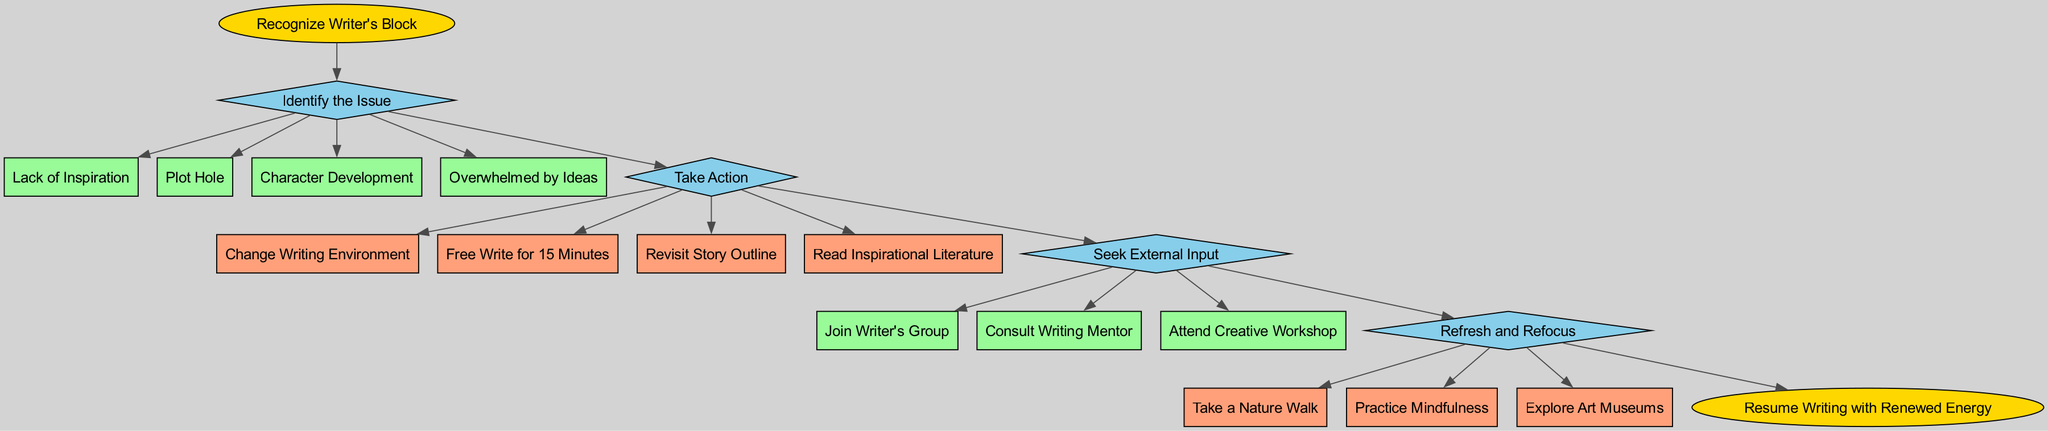What is the starting point of the flowchart? The starting point is represented by the first node labeled "Recognize Writer's Block." This node is connected to the "Identify the Issue" stage, indicating it is the initial action.
Answer: Recognize Writer's Block How many stages are present in the flowchart? The flowchart includes four distinct stages: "Identify the Issue," "Take Action," "Seek External Input," and "Refresh and Refocus." By counting these stages, we can determine the total.
Answer: 4 What is one option in the "Identify the Issue" stage? In the "Identify the Issue" stage, one of the listed options is "Lack of Inspiration." This represents a potential reason for experiencing writer's block.
Answer: Lack of Inspiration What action should be taken if the writer feels overwhelmed by ideas? When the feeling of being overwhelmed by ideas is identified, the writer should proceed to the "Take Action" stage. One action listed there is to "Free Write for 15 Minutes." This indicates a direct approach to cope with the issue.
Answer: Free Write for 15 Minutes What is the last action in the flowchart before resuming writing? The flowchart ends with the node "Resume Writing with Renewed Energy." This indicates that after taking previous steps, the final action is to return to writing with a fresh mindset.
Answer: Resume Writing with Renewed Energy If a writer wants external input, what is one of the options they can choose? In the "Seek External Input" stage, one option available is "Join Writer's Group." This provides a way for writers to gather support and insights from fellow writers.
Answer: Join Writer's Group How does the "Take Action" stage connect to the end of the flowchart? The "Take Action" stage leads to one or more steps, which are all connected to a subsequent stage. Finally, all stages connect in a chain to reach the end node that conveys the completion of the flow. This allows each action to contribute to achieving the final goal.
Answer: Through steps leading to end 